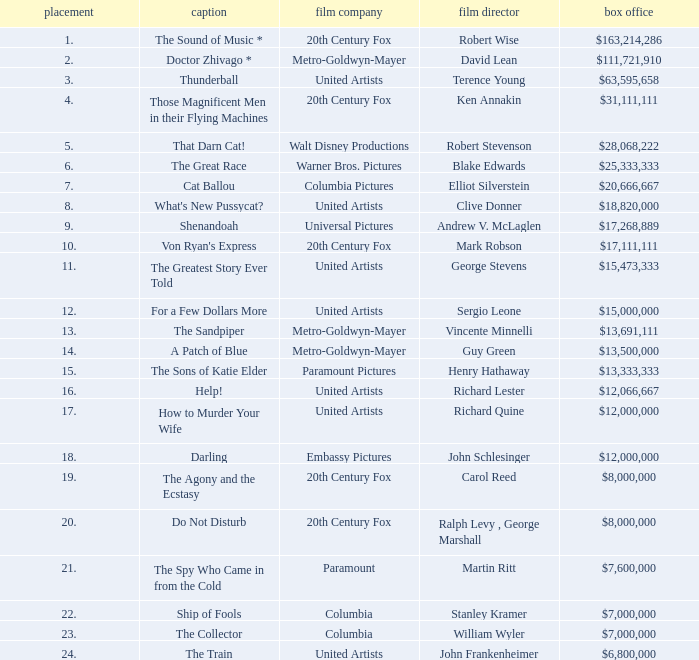What is Title, when Studio is "Embassy Pictures"? Darling. Would you be able to parse every entry in this table? {'header': ['placement', 'caption', 'film company', 'film director', 'box office'], 'rows': [['1.', 'The Sound of Music *', '20th Century Fox', 'Robert Wise', '$163,214,286'], ['2.', 'Doctor Zhivago *', 'Metro-Goldwyn-Mayer', 'David Lean', '$111,721,910'], ['3.', 'Thunderball', 'United Artists', 'Terence Young', '$63,595,658'], ['4.', 'Those Magnificent Men in their Flying Machines', '20th Century Fox', 'Ken Annakin', '$31,111,111'], ['5.', 'That Darn Cat!', 'Walt Disney Productions', 'Robert Stevenson', '$28,068,222'], ['6.', 'The Great Race', 'Warner Bros. Pictures', 'Blake Edwards', '$25,333,333'], ['7.', 'Cat Ballou', 'Columbia Pictures', 'Elliot Silverstein', '$20,666,667'], ['8.', "What's New Pussycat?", 'United Artists', 'Clive Donner', '$18,820,000'], ['9.', 'Shenandoah', 'Universal Pictures', 'Andrew V. McLaglen', '$17,268,889'], ['10.', "Von Ryan's Express", '20th Century Fox', 'Mark Robson', '$17,111,111'], ['11.', 'The Greatest Story Ever Told', 'United Artists', 'George Stevens', '$15,473,333'], ['12.', 'For a Few Dollars More', 'United Artists', 'Sergio Leone', '$15,000,000'], ['13.', 'The Sandpiper', 'Metro-Goldwyn-Mayer', 'Vincente Minnelli', '$13,691,111'], ['14.', 'A Patch of Blue', 'Metro-Goldwyn-Mayer', 'Guy Green', '$13,500,000'], ['15.', 'The Sons of Katie Elder', 'Paramount Pictures', 'Henry Hathaway', '$13,333,333'], ['16.', 'Help!', 'United Artists', 'Richard Lester', '$12,066,667'], ['17.', 'How to Murder Your Wife', 'United Artists', 'Richard Quine', '$12,000,000'], ['18.', 'Darling', 'Embassy Pictures', 'John Schlesinger', '$12,000,000'], ['19.', 'The Agony and the Ecstasy', '20th Century Fox', 'Carol Reed', '$8,000,000'], ['20.', 'Do Not Disturb', '20th Century Fox', 'Ralph Levy , George Marshall', '$8,000,000'], ['21.', 'The Spy Who Came in from the Cold', 'Paramount', 'Martin Ritt', '$7,600,000'], ['22.', 'Ship of Fools', 'Columbia', 'Stanley Kramer', '$7,000,000'], ['23.', 'The Collector', 'Columbia', 'William Wyler', '$7,000,000'], ['24.', 'The Train', 'United Artists', 'John Frankenheimer', '$6,800,000']]} 